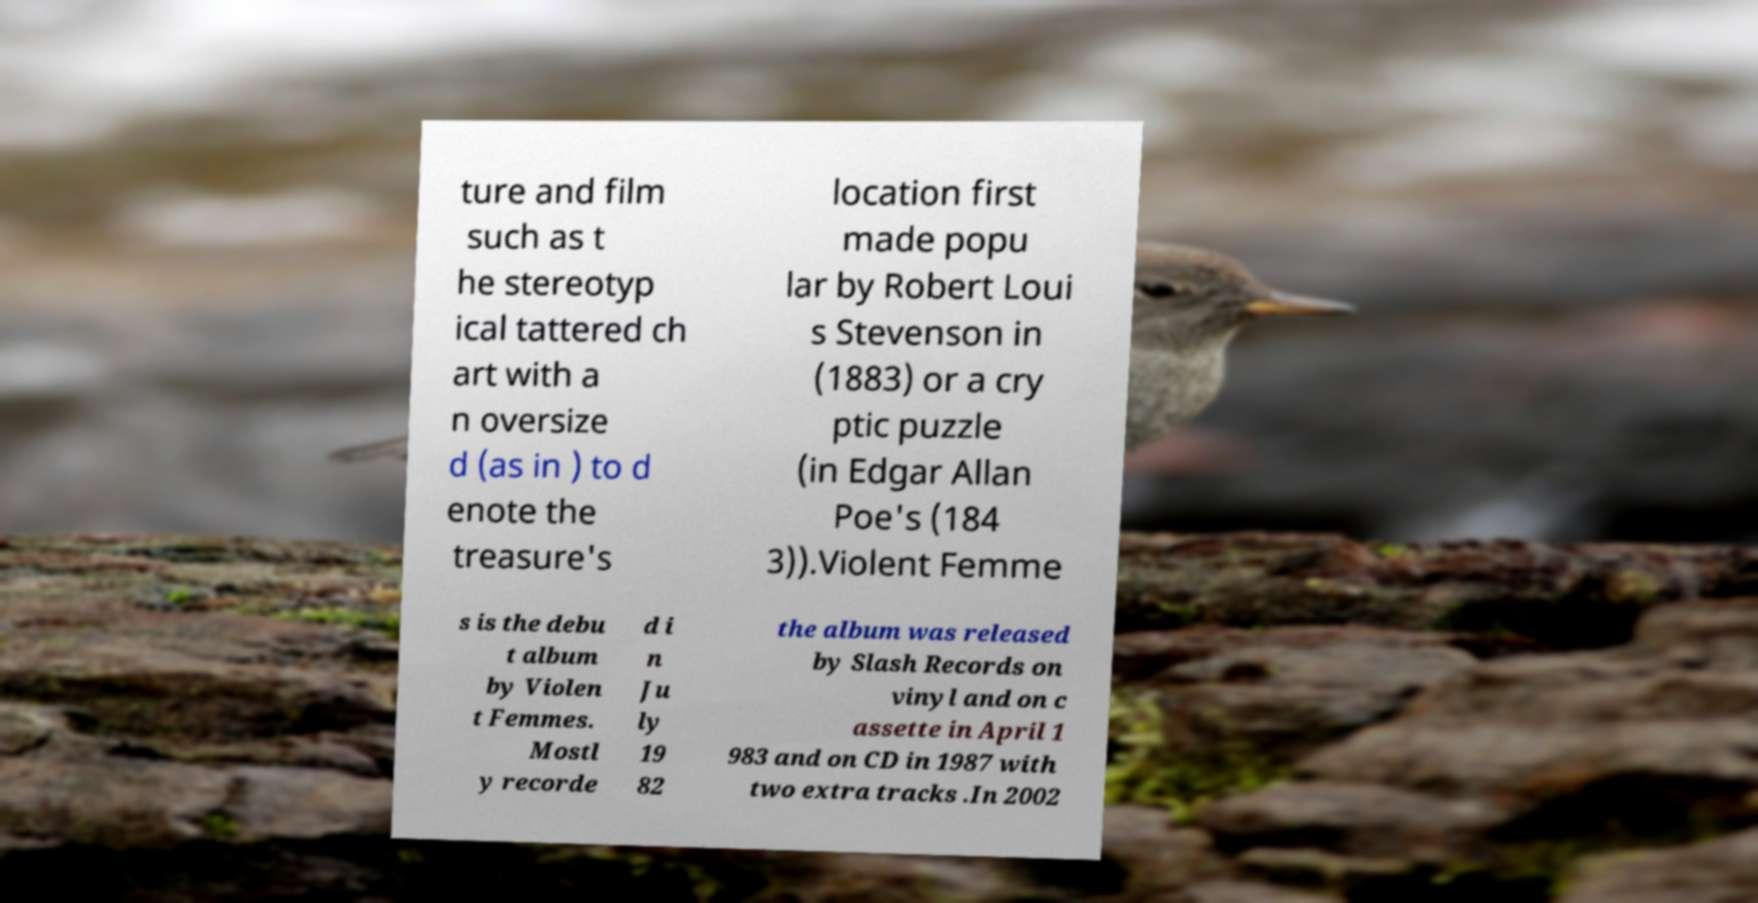Could you extract and type out the text from this image? ture and film such as t he stereotyp ical tattered ch art with a n oversize d (as in ) to d enote the treasure's location first made popu lar by Robert Loui s Stevenson in (1883) or a cry ptic puzzle (in Edgar Allan Poe's (184 3)).Violent Femme s is the debu t album by Violen t Femmes. Mostl y recorde d i n Ju ly 19 82 the album was released by Slash Records on vinyl and on c assette in April 1 983 and on CD in 1987 with two extra tracks .In 2002 